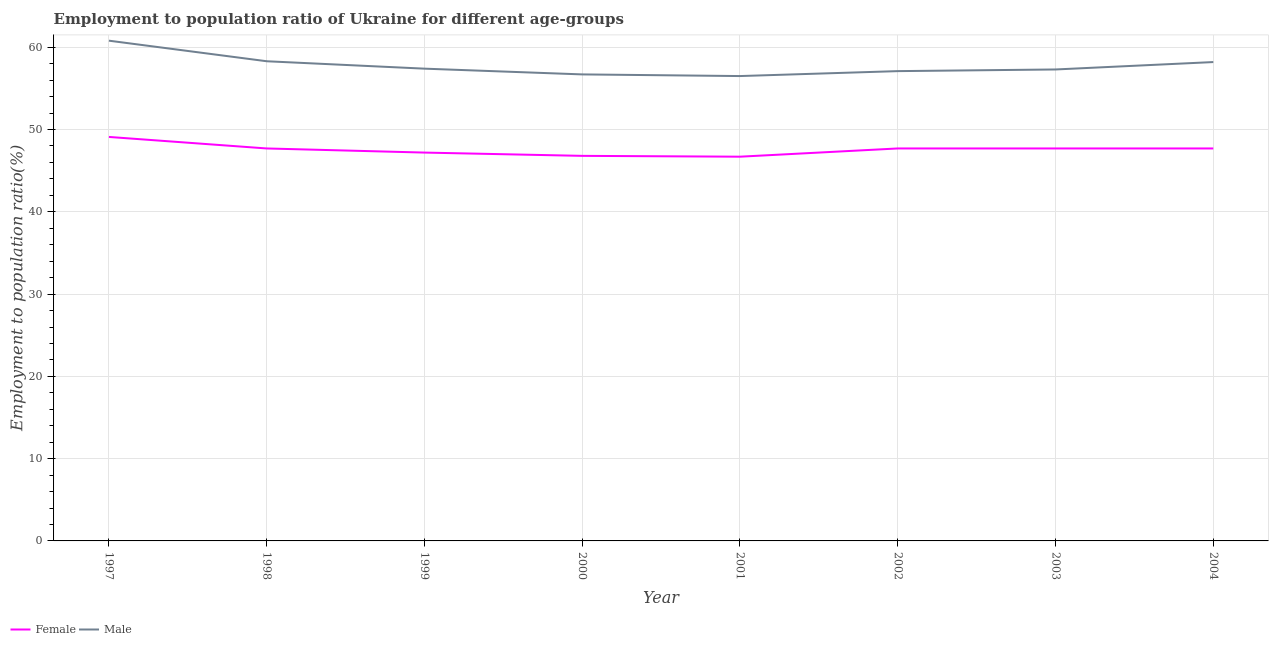Does the line corresponding to employment to population ratio(male) intersect with the line corresponding to employment to population ratio(female)?
Offer a very short reply. No. Is the number of lines equal to the number of legend labels?
Make the answer very short. Yes. What is the employment to population ratio(female) in 2003?
Provide a succinct answer. 47.7. Across all years, what is the maximum employment to population ratio(female)?
Ensure brevity in your answer.  49.1. Across all years, what is the minimum employment to population ratio(male)?
Ensure brevity in your answer.  56.5. In which year was the employment to population ratio(female) minimum?
Provide a short and direct response. 2001. What is the total employment to population ratio(female) in the graph?
Your answer should be compact. 380.6. What is the difference between the employment to population ratio(male) in 1998 and that in 2004?
Offer a very short reply. 0.1. What is the difference between the employment to population ratio(male) in 1997 and the employment to population ratio(female) in 2002?
Your response must be concise. 13.1. What is the average employment to population ratio(male) per year?
Your answer should be very brief. 57.79. In the year 2000, what is the difference between the employment to population ratio(male) and employment to population ratio(female)?
Provide a short and direct response. 9.9. What is the ratio of the employment to population ratio(male) in 1999 to that in 2001?
Make the answer very short. 1.02. Is the employment to population ratio(female) in 1999 less than that in 2003?
Your answer should be very brief. Yes. What is the difference between the highest and the lowest employment to population ratio(female)?
Make the answer very short. 2.4. In how many years, is the employment to population ratio(male) greater than the average employment to population ratio(male) taken over all years?
Your response must be concise. 3. Is the employment to population ratio(female) strictly greater than the employment to population ratio(male) over the years?
Keep it short and to the point. No. What is the difference between two consecutive major ticks on the Y-axis?
Your answer should be very brief. 10. Are the values on the major ticks of Y-axis written in scientific E-notation?
Ensure brevity in your answer.  No. Does the graph contain any zero values?
Give a very brief answer. No. How are the legend labels stacked?
Make the answer very short. Horizontal. What is the title of the graph?
Provide a succinct answer. Employment to population ratio of Ukraine for different age-groups. What is the label or title of the X-axis?
Keep it short and to the point. Year. What is the Employment to population ratio(%) of Female in 1997?
Provide a succinct answer. 49.1. What is the Employment to population ratio(%) in Male in 1997?
Ensure brevity in your answer.  60.8. What is the Employment to population ratio(%) in Female in 1998?
Provide a short and direct response. 47.7. What is the Employment to population ratio(%) in Male in 1998?
Your response must be concise. 58.3. What is the Employment to population ratio(%) of Female in 1999?
Provide a short and direct response. 47.2. What is the Employment to population ratio(%) of Male in 1999?
Ensure brevity in your answer.  57.4. What is the Employment to population ratio(%) in Female in 2000?
Provide a succinct answer. 46.8. What is the Employment to population ratio(%) of Male in 2000?
Provide a succinct answer. 56.7. What is the Employment to population ratio(%) of Female in 2001?
Make the answer very short. 46.7. What is the Employment to population ratio(%) in Male in 2001?
Your answer should be compact. 56.5. What is the Employment to population ratio(%) of Female in 2002?
Make the answer very short. 47.7. What is the Employment to population ratio(%) of Male in 2002?
Offer a terse response. 57.1. What is the Employment to population ratio(%) in Female in 2003?
Provide a short and direct response. 47.7. What is the Employment to population ratio(%) of Male in 2003?
Your answer should be very brief. 57.3. What is the Employment to population ratio(%) of Female in 2004?
Provide a short and direct response. 47.7. What is the Employment to population ratio(%) in Male in 2004?
Make the answer very short. 58.2. Across all years, what is the maximum Employment to population ratio(%) in Female?
Your answer should be very brief. 49.1. Across all years, what is the maximum Employment to population ratio(%) in Male?
Your answer should be very brief. 60.8. Across all years, what is the minimum Employment to population ratio(%) of Female?
Your answer should be very brief. 46.7. Across all years, what is the minimum Employment to population ratio(%) in Male?
Provide a short and direct response. 56.5. What is the total Employment to population ratio(%) in Female in the graph?
Make the answer very short. 380.6. What is the total Employment to population ratio(%) in Male in the graph?
Offer a very short reply. 462.3. What is the difference between the Employment to population ratio(%) of Female in 1997 and that in 1999?
Keep it short and to the point. 1.9. What is the difference between the Employment to population ratio(%) in Male in 1997 and that in 1999?
Your response must be concise. 3.4. What is the difference between the Employment to population ratio(%) of Female in 1997 and that in 2000?
Your answer should be very brief. 2.3. What is the difference between the Employment to population ratio(%) in Male in 1997 and that in 2000?
Offer a very short reply. 4.1. What is the difference between the Employment to population ratio(%) of Female in 1997 and that in 2002?
Make the answer very short. 1.4. What is the difference between the Employment to population ratio(%) in Male in 1997 and that in 2003?
Provide a short and direct response. 3.5. What is the difference between the Employment to population ratio(%) in Female in 1997 and that in 2004?
Offer a terse response. 1.4. What is the difference between the Employment to population ratio(%) of Female in 1998 and that in 2000?
Your answer should be compact. 0.9. What is the difference between the Employment to population ratio(%) of Female in 1998 and that in 2002?
Provide a succinct answer. 0. What is the difference between the Employment to population ratio(%) of Male in 1998 and that in 2002?
Make the answer very short. 1.2. What is the difference between the Employment to population ratio(%) of Female in 1998 and that in 2003?
Your response must be concise. 0. What is the difference between the Employment to population ratio(%) in Male in 1998 and that in 2004?
Your answer should be compact. 0.1. What is the difference between the Employment to population ratio(%) of Male in 1999 and that in 2000?
Offer a terse response. 0.7. What is the difference between the Employment to population ratio(%) in Female in 1999 and that in 2001?
Your answer should be compact. 0.5. What is the difference between the Employment to population ratio(%) of Female in 1999 and that in 2003?
Your answer should be very brief. -0.5. What is the difference between the Employment to population ratio(%) in Male in 1999 and that in 2003?
Keep it short and to the point. 0.1. What is the difference between the Employment to population ratio(%) in Male in 1999 and that in 2004?
Offer a terse response. -0.8. What is the difference between the Employment to population ratio(%) in Female in 2000 and that in 2001?
Your response must be concise. 0.1. What is the difference between the Employment to population ratio(%) in Male in 2000 and that in 2001?
Give a very brief answer. 0.2. What is the difference between the Employment to population ratio(%) of Female in 2000 and that in 2002?
Your response must be concise. -0.9. What is the difference between the Employment to population ratio(%) of Male in 2000 and that in 2002?
Ensure brevity in your answer.  -0.4. What is the difference between the Employment to population ratio(%) of Female in 2000 and that in 2003?
Your answer should be compact. -0.9. What is the difference between the Employment to population ratio(%) in Male in 2000 and that in 2004?
Make the answer very short. -1.5. What is the difference between the Employment to population ratio(%) of Female in 2001 and that in 2002?
Provide a succinct answer. -1. What is the difference between the Employment to population ratio(%) of Male in 2001 and that in 2002?
Offer a very short reply. -0.6. What is the difference between the Employment to population ratio(%) of Female in 2001 and that in 2003?
Make the answer very short. -1. What is the difference between the Employment to population ratio(%) of Male in 2001 and that in 2003?
Your response must be concise. -0.8. What is the difference between the Employment to population ratio(%) of Female in 2001 and that in 2004?
Provide a succinct answer. -1. What is the difference between the Employment to population ratio(%) in Male in 2001 and that in 2004?
Provide a succinct answer. -1.7. What is the difference between the Employment to population ratio(%) in Female in 2002 and that in 2003?
Provide a succinct answer. 0. What is the difference between the Employment to population ratio(%) in Male in 2002 and that in 2003?
Provide a short and direct response. -0.2. What is the difference between the Employment to population ratio(%) in Male in 2002 and that in 2004?
Offer a terse response. -1.1. What is the difference between the Employment to population ratio(%) of Female in 2003 and that in 2004?
Provide a succinct answer. 0. What is the difference between the Employment to population ratio(%) of Female in 1997 and the Employment to population ratio(%) of Male in 2000?
Offer a terse response. -7.6. What is the difference between the Employment to population ratio(%) of Female in 1997 and the Employment to population ratio(%) of Male in 2001?
Provide a short and direct response. -7.4. What is the difference between the Employment to population ratio(%) in Female in 1997 and the Employment to population ratio(%) in Male in 2002?
Your answer should be very brief. -8. What is the difference between the Employment to population ratio(%) in Female in 1998 and the Employment to population ratio(%) in Male in 1999?
Provide a short and direct response. -9.7. What is the difference between the Employment to population ratio(%) in Female in 1998 and the Employment to population ratio(%) in Male in 2000?
Ensure brevity in your answer.  -9. What is the difference between the Employment to population ratio(%) of Female in 1998 and the Employment to population ratio(%) of Male in 2001?
Make the answer very short. -8.8. What is the difference between the Employment to population ratio(%) in Female in 1998 and the Employment to population ratio(%) in Male in 2002?
Offer a terse response. -9.4. What is the difference between the Employment to population ratio(%) in Female in 1998 and the Employment to population ratio(%) in Male in 2004?
Ensure brevity in your answer.  -10.5. What is the difference between the Employment to population ratio(%) in Female in 1999 and the Employment to population ratio(%) in Male in 2000?
Keep it short and to the point. -9.5. What is the difference between the Employment to population ratio(%) in Female in 1999 and the Employment to population ratio(%) in Male in 2001?
Your answer should be compact. -9.3. What is the difference between the Employment to population ratio(%) of Female in 1999 and the Employment to population ratio(%) of Male in 2002?
Your answer should be compact. -9.9. What is the difference between the Employment to population ratio(%) in Female in 1999 and the Employment to population ratio(%) in Male in 2003?
Keep it short and to the point. -10.1. What is the difference between the Employment to population ratio(%) of Female in 1999 and the Employment to population ratio(%) of Male in 2004?
Ensure brevity in your answer.  -11. What is the difference between the Employment to population ratio(%) of Female in 2000 and the Employment to population ratio(%) of Male in 2001?
Your answer should be very brief. -9.7. What is the difference between the Employment to population ratio(%) in Female in 2000 and the Employment to population ratio(%) in Male in 2002?
Offer a very short reply. -10.3. What is the difference between the Employment to population ratio(%) of Female in 2001 and the Employment to population ratio(%) of Male in 2004?
Make the answer very short. -11.5. What is the average Employment to population ratio(%) of Female per year?
Make the answer very short. 47.58. What is the average Employment to population ratio(%) in Male per year?
Your response must be concise. 57.79. In the year 1997, what is the difference between the Employment to population ratio(%) in Female and Employment to population ratio(%) in Male?
Your answer should be compact. -11.7. In the year 1999, what is the difference between the Employment to population ratio(%) in Female and Employment to population ratio(%) in Male?
Give a very brief answer. -10.2. In the year 2000, what is the difference between the Employment to population ratio(%) of Female and Employment to population ratio(%) of Male?
Offer a very short reply. -9.9. What is the ratio of the Employment to population ratio(%) in Female in 1997 to that in 1998?
Keep it short and to the point. 1.03. What is the ratio of the Employment to population ratio(%) of Male in 1997 to that in 1998?
Offer a very short reply. 1.04. What is the ratio of the Employment to population ratio(%) in Female in 1997 to that in 1999?
Keep it short and to the point. 1.04. What is the ratio of the Employment to population ratio(%) in Male in 1997 to that in 1999?
Provide a succinct answer. 1.06. What is the ratio of the Employment to population ratio(%) in Female in 1997 to that in 2000?
Your answer should be compact. 1.05. What is the ratio of the Employment to population ratio(%) of Male in 1997 to that in 2000?
Make the answer very short. 1.07. What is the ratio of the Employment to population ratio(%) of Female in 1997 to that in 2001?
Ensure brevity in your answer.  1.05. What is the ratio of the Employment to population ratio(%) in Male in 1997 to that in 2001?
Keep it short and to the point. 1.08. What is the ratio of the Employment to population ratio(%) in Female in 1997 to that in 2002?
Provide a short and direct response. 1.03. What is the ratio of the Employment to population ratio(%) of Male in 1997 to that in 2002?
Your response must be concise. 1.06. What is the ratio of the Employment to population ratio(%) in Female in 1997 to that in 2003?
Your answer should be compact. 1.03. What is the ratio of the Employment to population ratio(%) of Male in 1997 to that in 2003?
Make the answer very short. 1.06. What is the ratio of the Employment to population ratio(%) of Female in 1997 to that in 2004?
Your answer should be very brief. 1.03. What is the ratio of the Employment to population ratio(%) of Male in 1997 to that in 2004?
Your answer should be compact. 1.04. What is the ratio of the Employment to population ratio(%) in Female in 1998 to that in 1999?
Ensure brevity in your answer.  1.01. What is the ratio of the Employment to population ratio(%) of Male in 1998 to that in 1999?
Your answer should be very brief. 1.02. What is the ratio of the Employment to population ratio(%) of Female in 1998 to that in 2000?
Provide a succinct answer. 1.02. What is the ratio of the Employment to population ratio(%) of Male in 1998 to that in 2000?
Provide a succinct answer. 1.03. What is the ratio of the Employment to population ratio(%) in Female in 1998 to that in 2001?
Offer a terse response. 1.02. What is the ratio of the Employment to population ratio(%) of Male in 1998 to that in 2001?
Ensure brevity in your answer.  1.03. What is the ratio of the Employment to population ratio(%) in Female in 1998 to that in 2002?
Provide a short and direct response. 1. What is the ratio of the Employment to population ratio(%) in Male in 1998 to that in 2002?
Provide a succinct answer. 1.02. What is the ratio of the Employment to population ratio(%) in Female in 1998 to that in 2003?
Offer a very short reply. 1. What is the ratio of the Employment to population ratio(%) in Male in 1998 to that in 2003?
Make the answer very short. 1.02. What is the ratio of the Employment to population ratio(%) of Male in 1998 to that in 2004?
Provide a succinct answer. 1. What is the ratio of the Employment to population ratio(%) in Female in 1999 to that in 2000?
Offer a very short reply. 1.01. What is the ratio of the Employment to population ratio(%) in Male in 1999 to that in 2000?
Your answer should be compact. 1.01. What is the ratio of the Employment to population ratio(%) of Female in 1999 to that in 2001?
Provide a short and direct response. 1.01. What is the ratio of the Employment to population ratio(%) in Male in 1999 to that in 2001?
Keep it short and to the point. 1.02. What is the ratio of the Employment to population ratio(%) in Female in 1999 to that in 2003?
Ensure brevity in your answer.  0.99. What is the ratio of the Employment to population ratio(%) of Male in 1999 to that in 2004?
Your answer should be compact. 0.99. What is the ratio of the Employment to population ratio(%) in Female in 2000 to that in 2001?
Keep it short and to the point. 1. What is the ratio of the Employment to population ratio(%) in Male in 2000 to that in 2001?
Offer a terse response. 1. What is the ratio of the Employment to population ratio(%) in Female in 2000 to that in 2002?
Your response must be concise. 0.98. What is the ratio of the Employment to population ratio(%) of Male in 2000 to that in 2002?
Offer a terse response. 0.99. What is the ratio of the Employment to population ratio(%) in Female in 2000 to that in 2003?
Keep it short and to the point. 0.98. What is the ratio of the Employment to population ratio(%) of Female in 2000 to that in 2004?
Your answer should be compact. 0.98. What is the ratio of the Employment to population ratio(%) in Male in 2000 to that in 2004?
Ensure brevity in your answer.  0.97. What is the ratio of the Employment to population ratio(%) of Female in 2001 to that in 2002?
Your answer should be very brief. 0.98. What is the ratio of the Employment to population ratio(%) in Male in 2001 to that in 2002?
Offer a very short reply. 0.99. What is the ratio of the Employment to population ratio(%) of Male in 2001 to that in 2004?
Offer a terse response. 0.97. What is the ratio of the Employment to population ratio(%) of Male in 2002 to that in 2003?
Offer a terse response. 1. What is the ratio of the Employment to population ratio(%) in Female in 2002 to that in 2004?
Keep it short and to the point. 1. What is the ratio of the Employment to population ratio(%) in Male in 2002 to that in 2004?
Offer a very short reply. 0.98. What is the ratio of the Employment to population ratio(%) of Male in 2003 to that in 2004?
Ensure brevity in your answer.  0.98. 